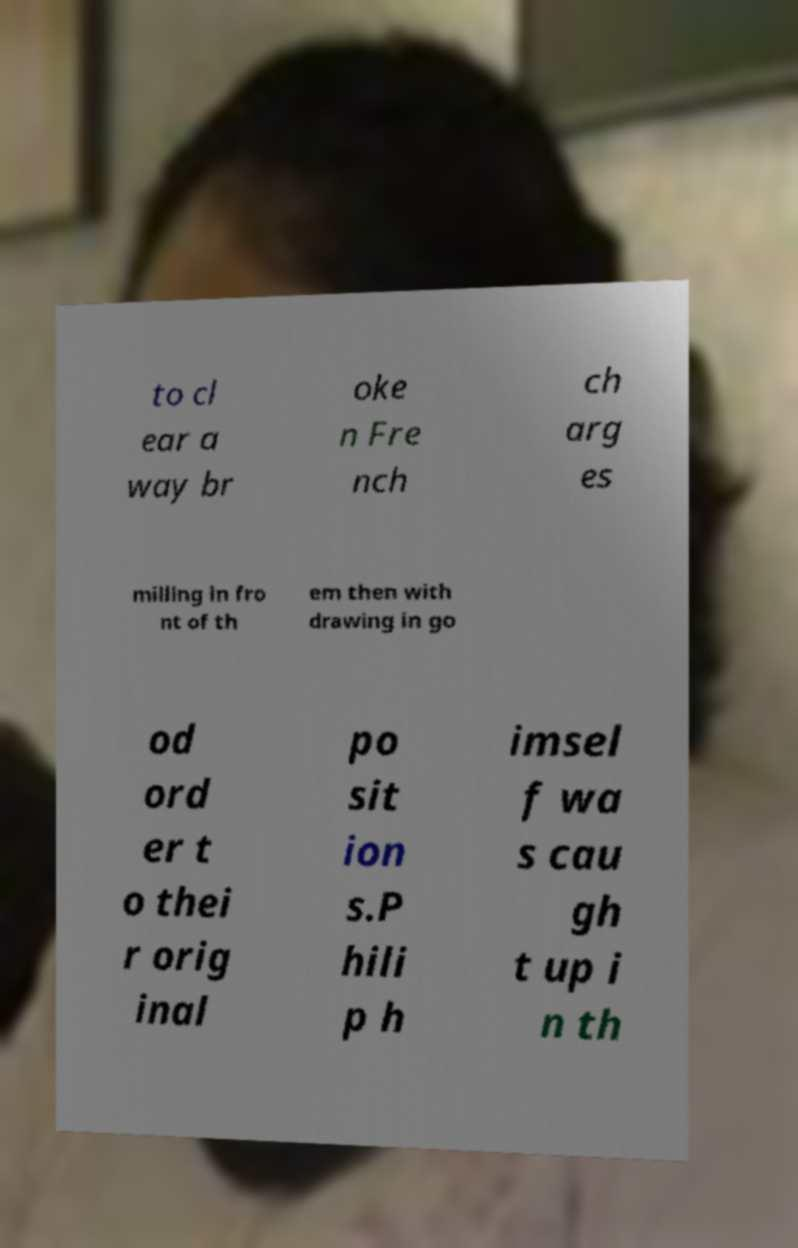What messages or text are displayed in this image? I need them in a readable, typed format. to cl ear a way br oke n Fre nch ch arg es milling in fro nt of th em then with drawing in go od ord er t o thei r orig inal po sit ion s.P hili p h imsel f wa s cau gh t up i n th 